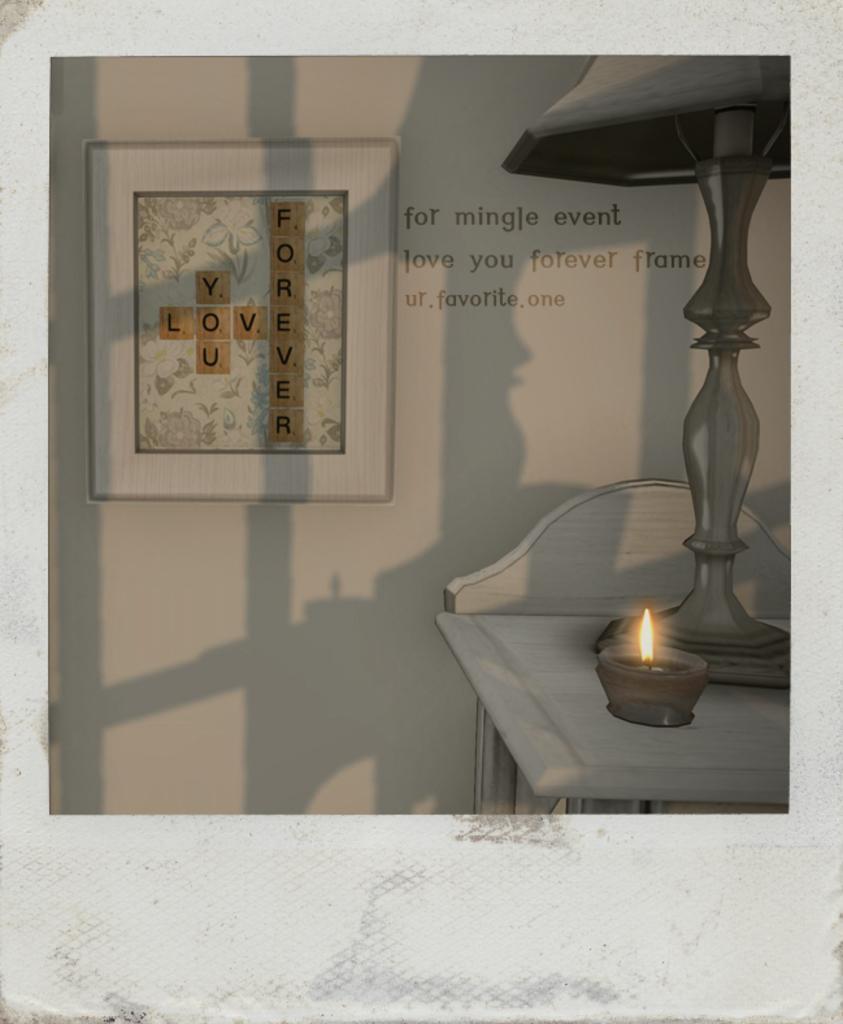In one or two sentences, can you explain what this image depicts? In this image we can see a photograph in which we can see a photo frame on the wall, we can see some text on the wall, lamp are kept on the table. 